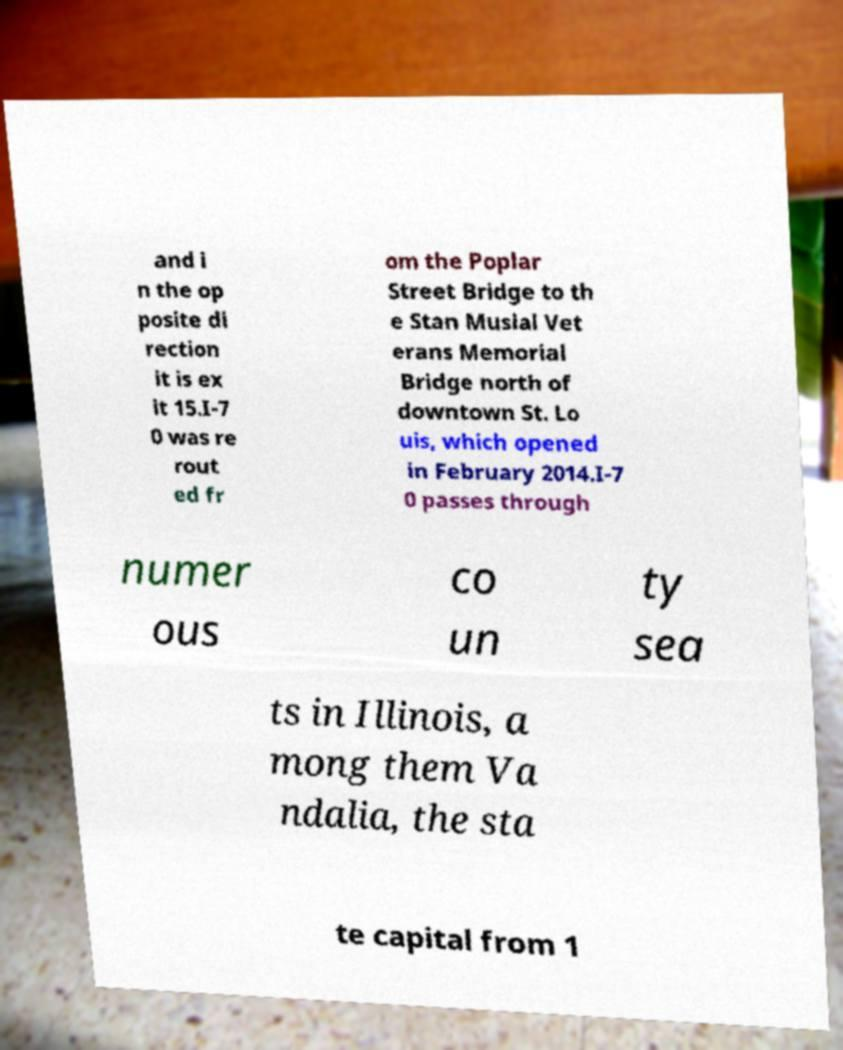There's text embedded in this image that I need extracted. Can you transcribe it verbatim? and i n the op posite di rection it is ex it 15.I-7 0 was re rout ed fr om the Poplar Street Bridge to th e Stan Musial Vet erans Memorial Bridge north of downtown St. Lo uis, which opened in February 2014.I-7 0 passes through numer ous co un ty sea ts in Illinois, a mong them Va ndalia, the sta te capital from 1 